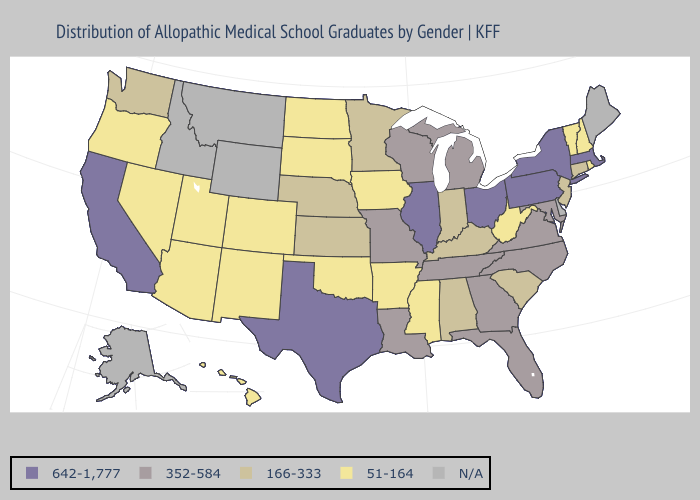Name the states that have a value in the range 166-333?
Keep it brief. Alabama, Connecticut, Indiana, Kansas, Kentucky, Minnesota, Nebraska, New Jersey, South Carolina, Washington. What is the value of California?
Quick response, please. 642-1,777. Does the map have missing data?
Be succinct. Yes. What is the highest value in the USA?
Be succinct. 642-1,777. Which states have the highest value in the USA?
Keep it brief. California, Illinois, Massachusetts, New York, Ohio, Pennsylvania, Texas. Among the states that border Illinois , does Wisconsin have the highest value?
Write a very short answer. Yes. What is the value of Washington?
Short answer required. 166-333. What is the highest value in states that border Louisiana?
Give a very brief answer. 642-1,777. Name the states that have a value in the range 352-584?
Answer briefly. Florida, Georgia, Louisiana, Maryland, Michigan, Missouri, North Carolina, Tennessee, Virginia, Wisconsin. What is the value of Utah?
Answer briefly. 51-164. Does Oklahoma have the lowest value in the USA?
Quick response, please. Yes. Name the states that have a value in the range N/A?
Quick response, please. Alaska, Delaware, Idaho, Maine, Montana, Wyoming. 